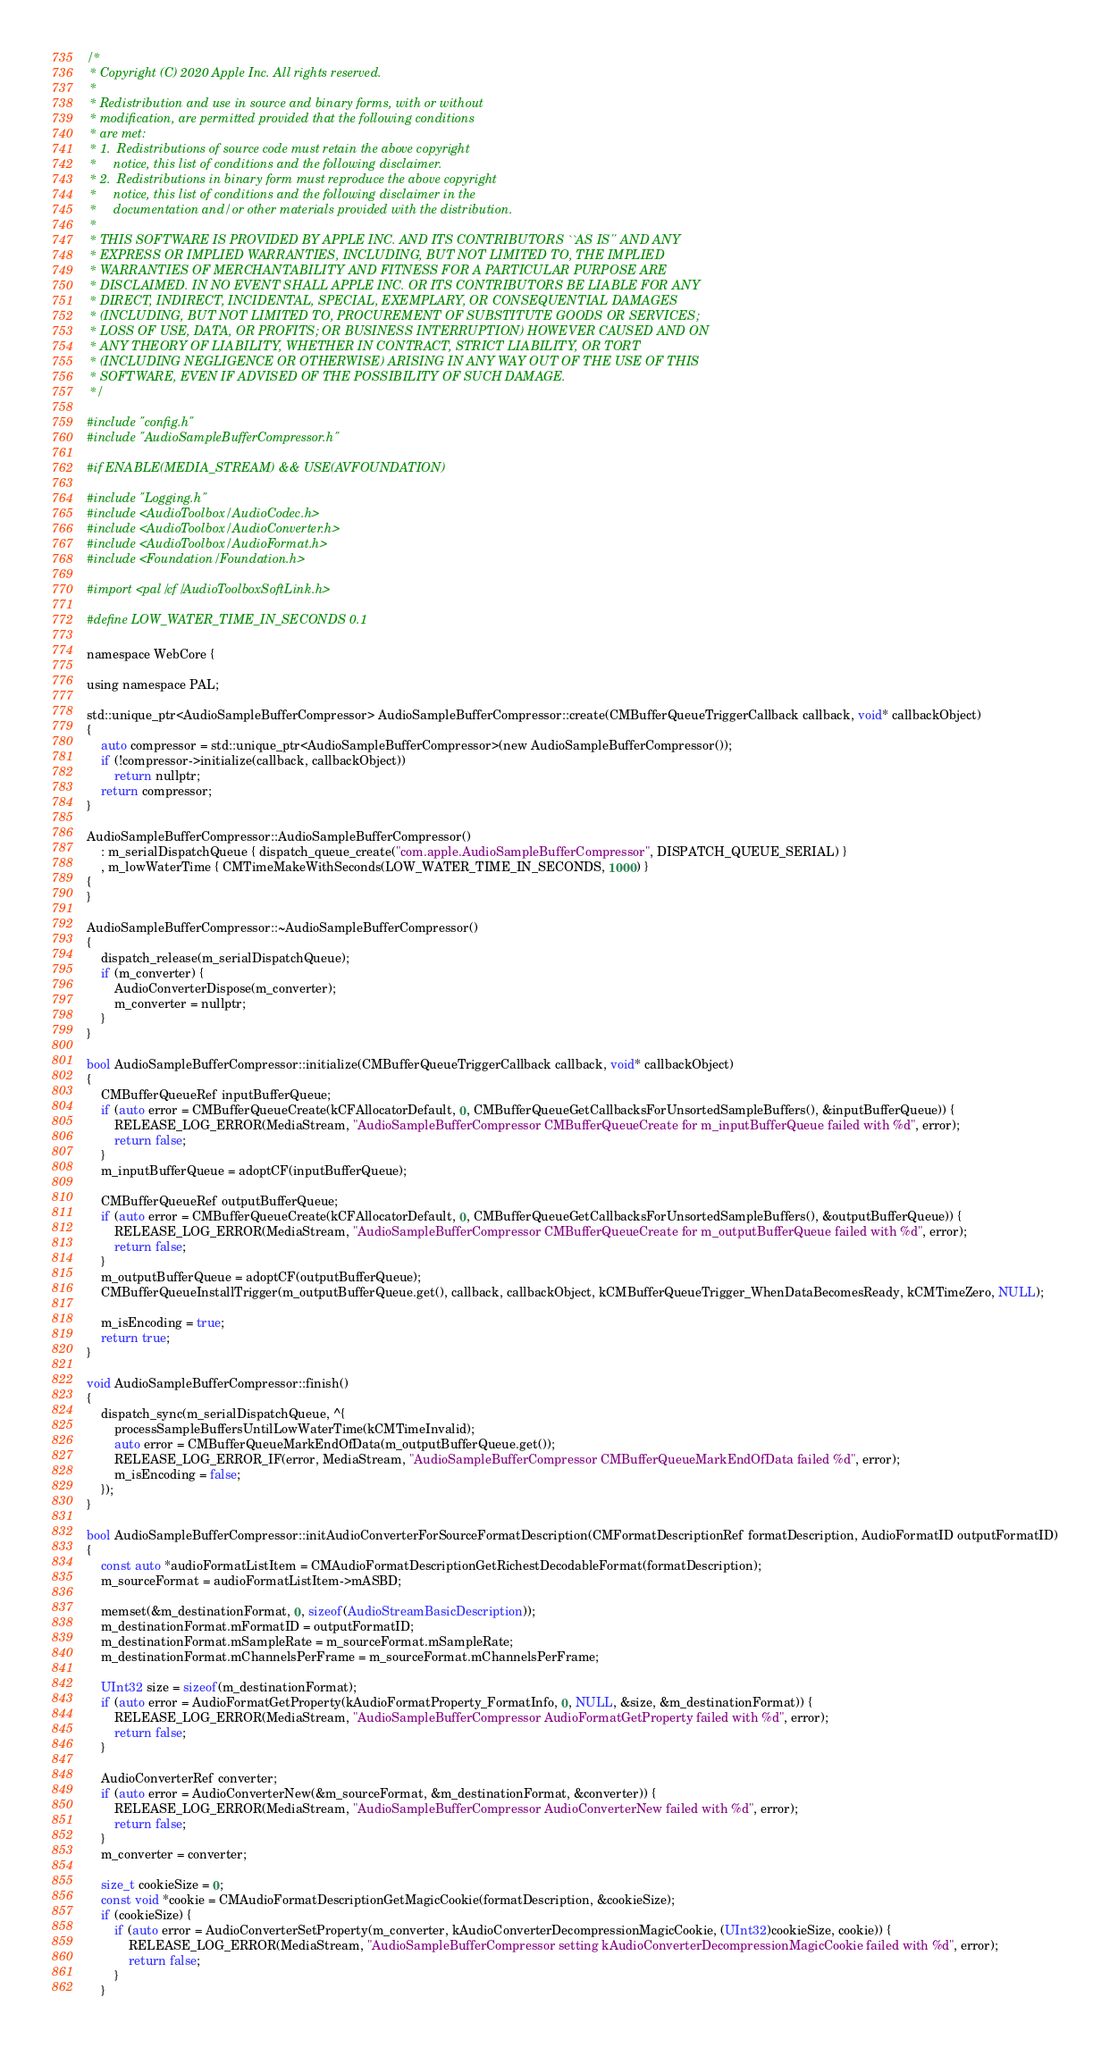Convert code to text. <code><loc_0><loc_0><loc_500><loc_500><_ObjectiveC_>/*
 * Copyright (C) 2020 Apple Inc. All rights reserved.
 *
 * Redistribution and use in source and binary forms, with or without
 * modification, are permitted provided that the following conditions
 * are met:
 * 1.  Redistributions of source code must retain the above copyright
 *     notice, this list of conditions and the following disclaimer.
 * 2.  Redistributions in binary form must reproduce the above copyright
 *     notice, this list of conditions and the following disclaimer in the
 *     documentation and/or other materials provided with the distribution.
 *
 * THIS SOFTWARE IS PROVIDED BY APPLE INC. AND ITS CONTRIBUTORS ``AS IS'' AND ANY
 * EXPRESS OR IMPLIED WARRANTIES, INCLUDING, BUT NOT LIMITED TO, THE IMPLIED
 * WARRANTIES OF MERCHANTABILITY AND FITNESS FOR A PARTICULAR PURPOSE ARE
 * DISCLAIMED. IN NO EVENT SHALL APPLE INC. OR ITS CONTRIBUTORS BE LIABLE FOR ANY
 * DIRECT, INDIRECT, INCIDENTAL, SPECIAL, EXEMPLARY, OR CONSEQUENTIAL DAMAGES
 * (INCLUDING, BUT NOT LIMITED TO, PROCUREMENT OF SUBSTITUTE GOODS OR SERVICES;
 * LOSS OF USE, DATA, OR PROFITS; OR BUSINESS INTERRUPTION) HOWEVER CAUSED AND ON
 * ANY THEORY OF LIABILITY, WHETHER IN CONTRACT, STRICT LIABILITY, OR TORT
 * (INCLUDING NEGLIGENCE OR OTHERWISE) ARISING IN ANY WAY OUT OF THE USE OF THIS
 * SOFTWARE, EVEN IF ADVISED OF THE POSSIBILITY OF SUCH DAMAGE.
 */

#include "config.h"
#include "AudioSampleBufferCompressor.h"

#if ENABLE(MEDIA_STREAM) && USE(AVFOUNDATION)

#include "Logging.h"
#include <AudioToolbox/AudioCodec.h>
#include <AudioToolbox/AudioConverter.h>
#include <AudioToolbox/AudioFormat.h>
#include <Foundation/Foundation.h>

#import <pal/cf/AudioToolboxSoftLink.h>

#define LOW_WATER_TIME_IN_SECONDS 0.1

namespace WebCore {

using namespace PAL;

std::unique_ptr<AudioSampleBufferCompressor> AudioSampleBufferCompressor::create(CMBufferQueueTriggerCallback callback, void* callbackObject)
{
    auto compressor = std::unique_ptr<AudioSampleBufferCompressor>(new AudioSampleBufferCompressor());
    if (!compressor->initialize(callback, callbackObject))
        return nullptr;
    return compressor;
}

AudioSampleBufferCompressor::AudioSampleBufferCompressor()
    : m_serialDispatchQueue { dispatch_queue_create("com.apple.AudioSampleBufferCompressor", DISPATCH_QUEUE_SERIAL) }
    , m_lowWaterTime { CMTimeMakeWithSeconds(LOW_WATER_TIME_IN_SECONDS, 1000) }
{
}

AudioSampleBufferCompressor::~AudioSampleBufferCompressor()
{
    dispatch_release(m_serialDispatchQueue);
    if (m_converter) {
        AudioConverterDispose(m_converter);
        m_converter = nullptr;
    }
}

bool AudioSampleBufferCompressor::initialize(CMBufferQueueTriggerCallback callback, void* callbackObject)
{
    CMBufferQueueRef inputBufferQueue;
    if (auto error = CMBufferQueueCreate(kCFAllocatorDefault, 0, CMBufferQueueGetCallbacksForUnsortedSampleBuffers(), &inputBufferQueue)) {
        RELEASE_LOG_ERROR(MediaStream, "AudioSampleBufferCompressor CMBufferQueueCreate for m_inputBufferQueue failed with %d", error);
        return false;
    }
    m_inputBufferQueue = adoptCF(inputBufferQueue);

    CMBufferQueueRef outputBufferQueue;
    if (auto error = CMBufferQueueCreate(kCFAllocatorDefault, 0, CMBufferQueueGetCallbacksForUnsortedSampleBuffers(), &outputBufferQueue)) {
        RELEASE_LOG_ERROR(MediaStream, "AudioSampleBufferCompressor CMBufferQueueCreate for m_outputBufferQueue failed with %d", error);
        return false;
    }
    m_outputBufferQueue = adoptCF(outputBufferQueue);
    CMBufferQueueInstallTrigger(m_outputBufferQueue.get(), callback, callbackObject, kCMBufferQueueTrigger_WhenDataBecomesReady, kCMTimeZero, NULL);

    m_isEncoding = true;
    return true;
}

void AudioSampleBufferCompressor::finish()
{
    dispatch_sync(m_serialDispatchQueue, ^{
        processSampleBuffersUntilLowWaterTime(kCMTimeInvalid);
        auto error = CMBufferQueueMarkEndOfData(m_outputBufferQueue.get());
        RELEASE_LOG_ERROR_IF(error, MediaStream, "AudioSampleBufferCompressor CMBufferQueueMarkEndOfData failed %d", error);
        m_isEncoding = false;
    });
}

bool AudioSampleBufferCompressor::initAudioConverterForSourceFormatDescription(CMFormatDescriptionRef formatDescription, AudioFormatID outputFormatID)
{
    const auto *audioFormatListItem = CMAudioFormatDescriptionGetRichestDecodableFormat(formatDescription);
    m_sourceFormat = audioFormatListItem->mASBD;

    memset(&m_destinationFormat, 0, sizeof(AudioStreamBasicDescription));
    m_destinationFormat.mFormatID = outputFormatID;
    m_destinationFormat.mSampleRate = m_sourceFormat.mSampleRate;
    m_destinationFormat.mChannelsPerFrame = m_sourceFormat.mChannelsPerFrame;

    UInt32 size = sizeof(m_destinationFormat);
    if (auto error = AudioFormatGetProperty(kAudioFormatProperty_FormatInfo, 0, NULL, &size, &m_destinationFormat)) {
        RELEASE_LOG_ERROR(MediaStream, "AudioSampleBufferCompressor AudioFormatGetProperty failed with %d", error);
        return false;
    }

    AudioConverterRef converter;
    if (auto error = AudioConverterNew(&m_sourceFormat, &m_destinationFormat, &converter)) {
        RELEASE_LOG_ERROR(MediaStream, "AudioSampleBufferCompressor AudioConverterNew failed with %d", error);
        return false;
    }
    m_converter = converter;

    size_t cookieSize = 0;
    const void *cookie = CMAudioFormatDescriptionGetMagicCookie(formatDescription, &cookieSize);
    if (cookieSize) {
        if (auto error = AudioConverterSetProperty(m_converter, kAudioConverterDecompressionMagicCookie, (UInt32)cookieSize, cookie)) {
            RELEASE_LOG_ERROR(MediaStream, "AudioSampleBufferCompressor setting kAudioConverterDecompressionMagicCookie failed with %d", error);
            return false;
        }
    }
</code> 